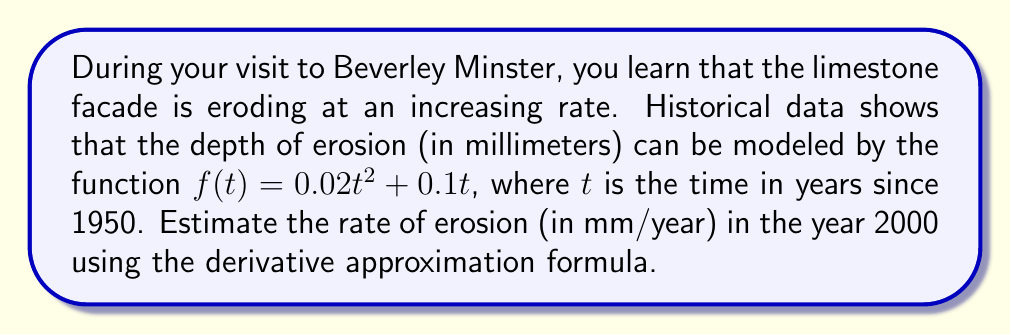Help me with this question. To estimate the rate of erosion in the year 2000, we need to use the derivative approximation formula:

$$f'(a) \approx \frac{f(a+h) - f(a)}{h}$$

Where $a$ is the point of interest (2000 - 1950 = 50 years since 1950), and $h$ is a small value (let's use $h = 0.1$).

Step 1: Calculate $f(a)$ and $f(a+h)$
$f(50) = 0.02(50)^2 + 0.1(50) = 50 + 5 = 55$ mm
$f(50.1) = 0.02(50.1)^2 + 0.1(50.1) = 50.2002 + 5.01 = 55.2102$ mm

Step 2: Apply the derivative approximation formula
$$f'(50) \approx \frac{f(50.1) - f(50)}{0.1} = \frac{55.2102 - 55}{0.1} = 2.102$$

Therefore, the estimated rate of erosion in the year 2000 is approximately 2.102 mm/year.
Answer: 2.102 mm/year 